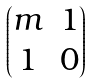<formula> <loc_0><loc_0><loc_500><loc_500>\begin{pmatrix} m & 1 \\ 1 & 0 \end{pmatrix}</formula> 